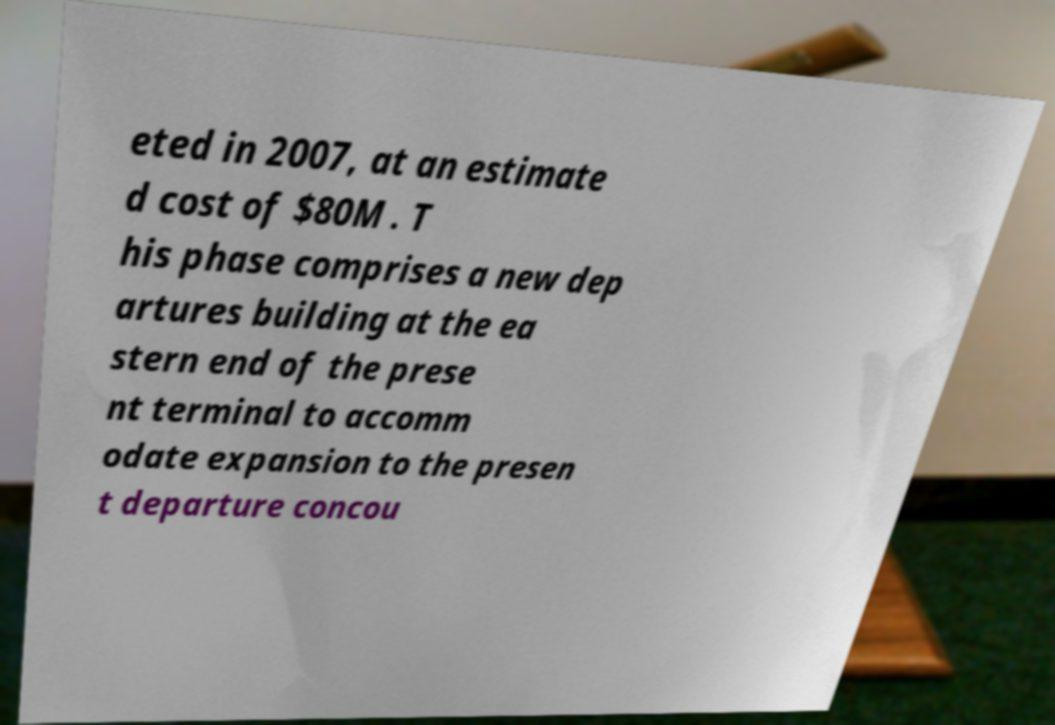I need the written content from this picture converted into text. Can you do that? eted in 2007, at an estimate d cost of $80M . T his phase comprises a new dep artures building at the ea stern end of the prese nt terminal to accomm odate expansion to the presen t departure concou 